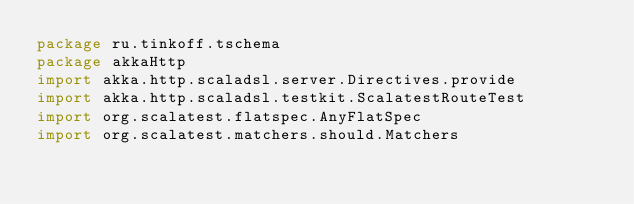<code> <loc_0><loc_0><loc_500><loc_500><_Scala_>package ru.tinkoff.tschema
package akkaHttp
import akka.http.scaladsl.server.Directives.provide
import akka.http.scaladsl.testkit.ScalatestRouteTest
import org.scalatest.flatspec.AnyFlatSpec
import org.scalatest.matchers.should.Matchers</code> 